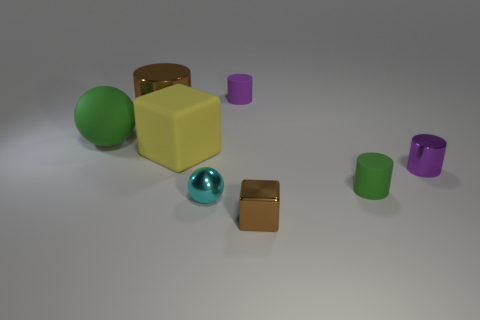Are the green ball and the large yellow block made of the same material?
Keep it short and to the point. Yes. Are there any brown cylinders to the left of the brown metal thing on the left side of the purple matte cylinder?
Give a very brief answer. No. Are there any other large green objects that have the same shape as the big green matte object?
Your answer should be very brief. No. Do the tiny metallic block and the tiny shiny cylinder have the same color?
Give a very brief answer. No. What is the material of the yellow thing that is right of the brown thing that is behind the yellow matte thing?
Make the answer very short. Rubber. How big is the cyan metallic sphere?
Ensure brevity in your answer.  Small. What is the size of the cube that is the same material as the tiny ball?
Give a very brief answer. Small. Do the green matte object in front of the yellow cube and the purple shiny cylinder have the same size?
Ensure brevity in your answer.  Yes. What shape is the green rubber object right of the small purple cylinder that is behind the purple object in front of the brown metal cylinder?
Provide a short and direct response. Cylinder. How many objects are either small purple metallic cylinders or tiny purple cylinders that are in front of the purple rubber thing?
Your answer should be compact. 1. 